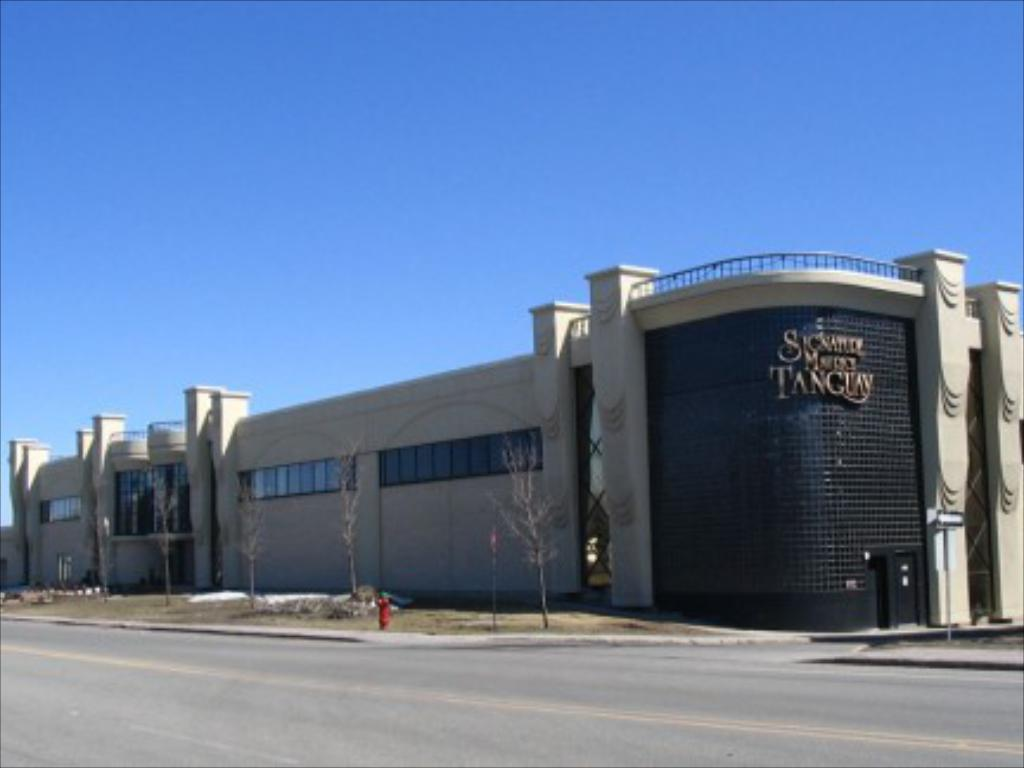What type of pathway is visible in the image? There is a road in the image. What object is present for fire safety? There is a hydrant in the image. What structures are supporting wires in the image? There are poles in the image. What type of vegetation can be seen in the image? There are trees in the image. What type of man-made structure is visible in the image? There is a building in the image. What is visible in the background of the image? The sky is visible in the background of the image. What type of condition is the zebra experiencing in the image? There is no zebra present in the image, so it is not possible to determine any conditions related to a zebra. 